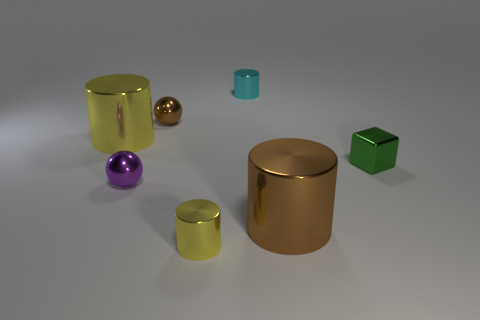What is the shape of the shiny object that is left of the big brown shiny cylinder and right of the tiny yellow metal object?
Your answer should be compact. Cylinder. What number of tiny purple objects have the same material as the small yellow thing?
Give a very brief answer. 1. Are there fewer metallic blocks that are behind the small brown shiny thing than tiny purple cubes?
Your answer should be very brief. No. There is a cyan object behind the small brown metal object; are there any metallic things on the right side of it?
Make the answer very short. Yes. Is there any other thing that has the same shape as the tiny green shiny thing?
Keep it short and to the point. No. Do the cyan object and the metallic cube have the same size?
Ensure brevity in your answer.  Yes. There is a small cylinder that is in front of the yellow thing that is on the left side of the metallic ball in front of the big yellow cylinder; what is it made of?
Offer a terse response. Metal. Is the number of large cylinders right of the green thing the same as the number of small purple objects?
Give a very brief answer. No. What number of objects are cyan things or purple shiny balls?
Provide a short and direct response. 2. There is a purple object that is the same material as the brown sphere; what shape is it?
Provide a short and direct response. Sphere. 